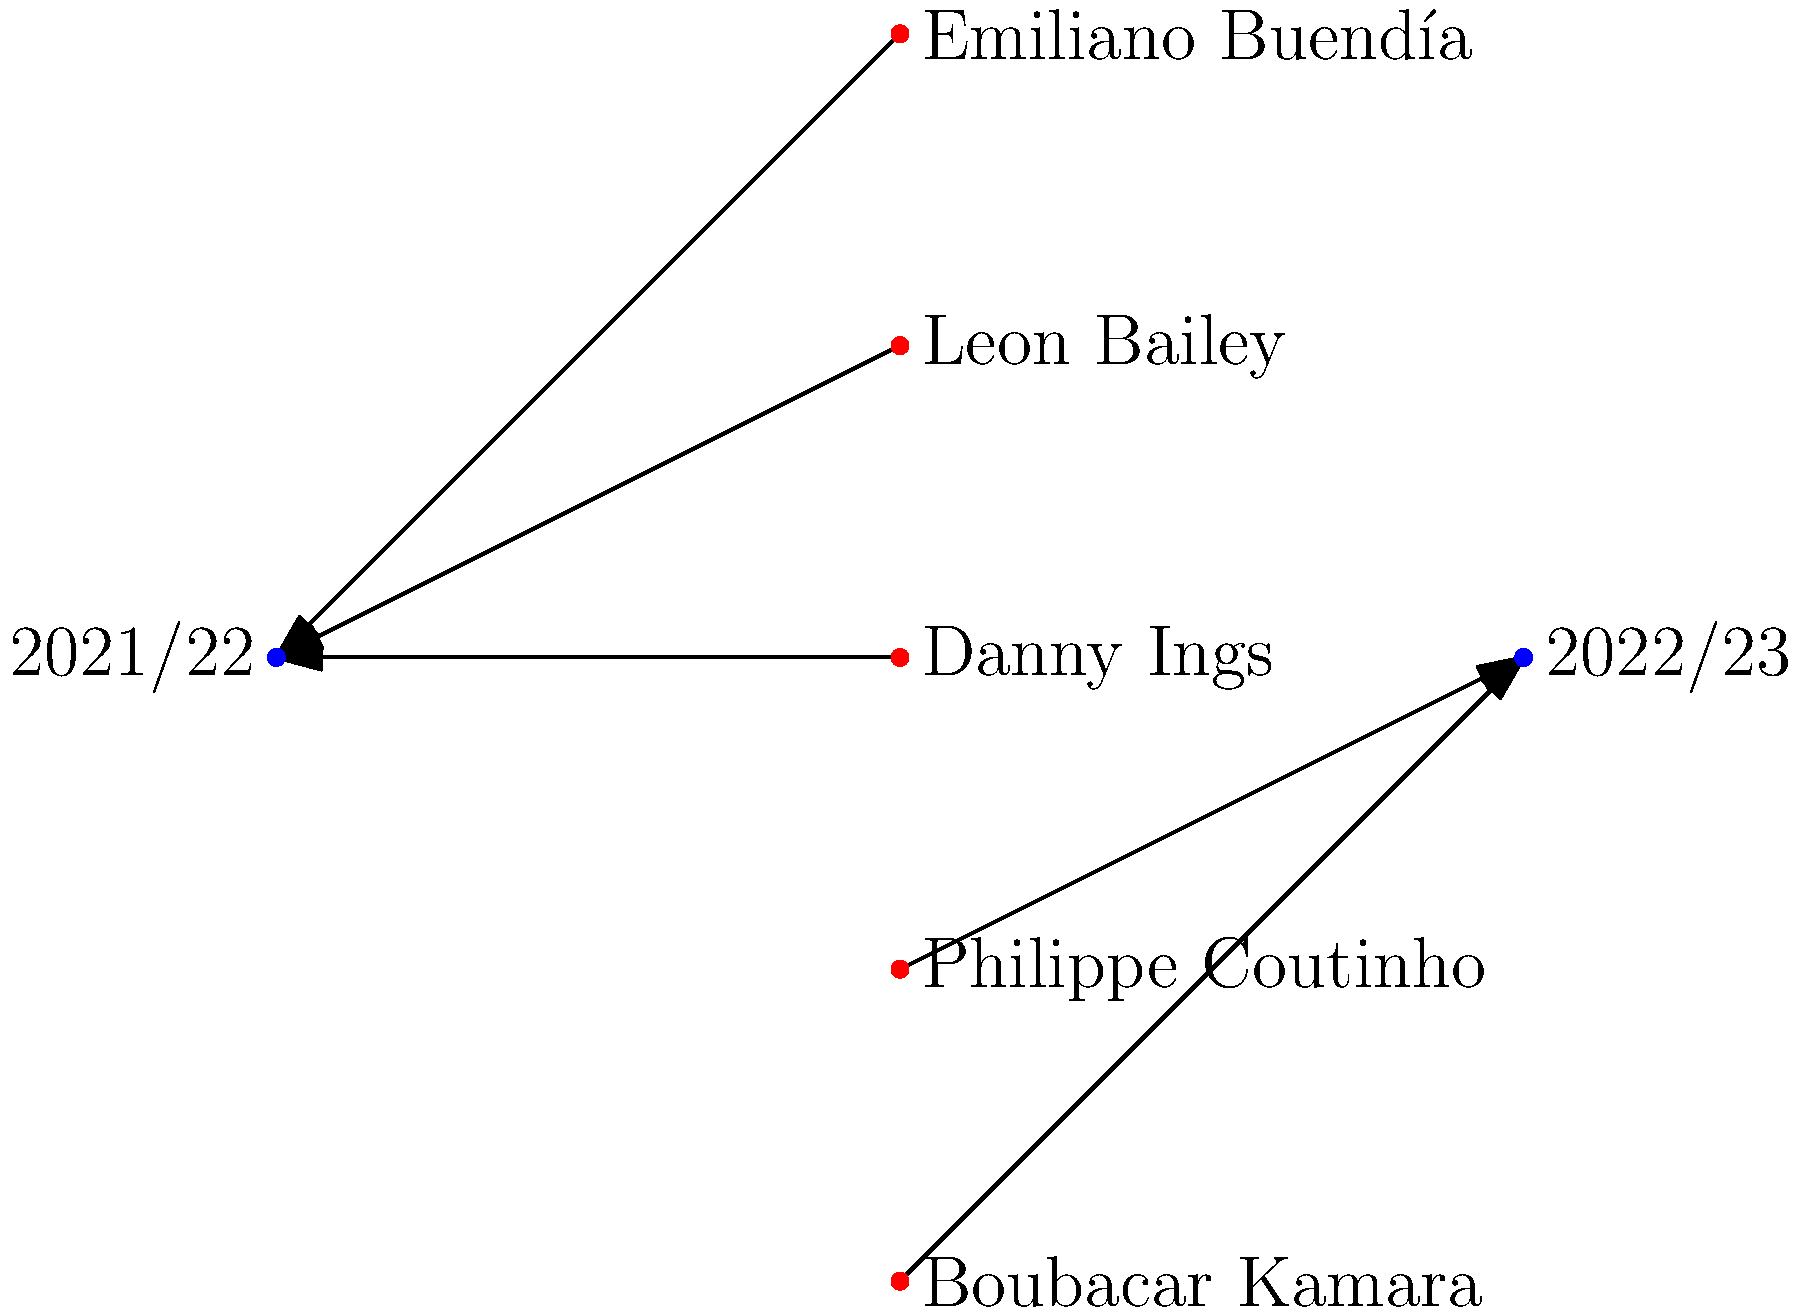In the bipartite graph representing Aston Villa's transfer activity, how many players were transferred in the 2021/22 season? To answer this question, we need to analyze the bipartite graph representing Aston Villa's transfer activity:

1. The graph shows two seasons: 2021/22 and 2022/23.
2. Players are represented by red dots, while seasons are represented by blue dots.
3. Arrows indicate the direction of transfer, pointing from players to seasons.

Let's count the players transferred in each season:

2021/22 season:
1. Emiliano Buendía
2. Leon Bailey
3. Danny Ings

2022/23 season:
1. Philippe Coutinho
2. Boubacar Kamara

By counting the arrows pointing to the 2021/22 season node, we can see that there are 3 players transferred in that season.
Answer: 3 